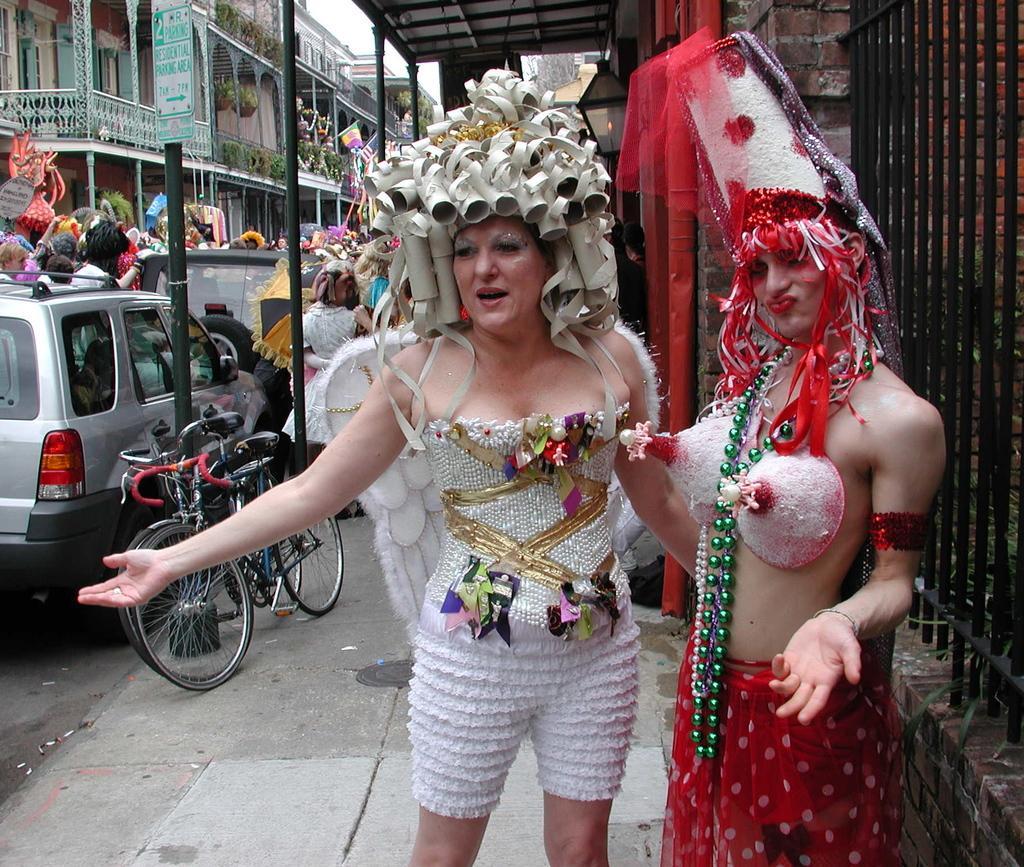Describe this image in one or two sentences. In this picture there is a woman who is wearing a cap and white dress, beside her we can see another woman who is wearing red dress. On the left there is a bicycle near to the car. Here we can see group of person standing near to the building. On the top there is a sky. Here we can see sign board. 